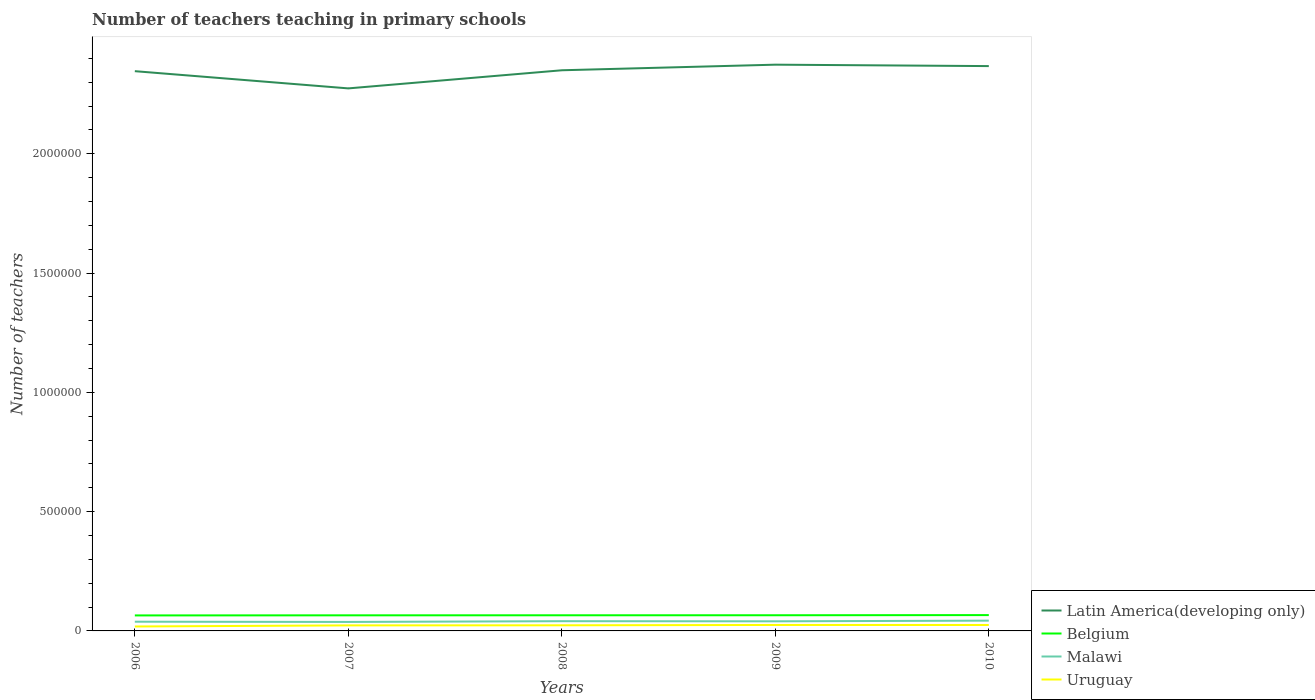Across all years, what is the maximum number of teachers teaching in primary schools in Latin America(developing only)?
Provide a succinct answer. 2.27e+06. What is the total number of teachers teaching in primary schools in Latin America(developing only) in the graph?
Your response must be concise. -9.34e+04. What is the difference between the highest and the second highest number of teachers teaching in primary schools in Uruguay?
Provide a succinct answer. 6331. What is the difference between the highest and the lowest number of teachers teaching in primary schools in Belgium?
Your answer should be compact. 2. Is the number of teachers teaching in primary schools in Uruguay strictly greater than the number of teachers teaching in primary schools in Belgium over the years?
Provide a succinct answer. Yes. Are the values on the major ticks of Y-axis written in scientific E-notation?
Provide a succinct answer. No. Does the graph contain any zero values?
Provide a succinct answer. No. Does the graph contain grids?
Your answer should be very brief. No. Where does the legend appear in the graph?
Your response must be concise. Bottom right. What is the title of the graph?
Your response must be concise. Number of teachers teaching in primary schools. Does "Central African Republic" appear as one of the legend labels in the graph?
Offer a very short reply. No. What is the label or title of the X-axis?
Offer a terse response. Years. What is the label or title of the Y-axis?
Ensure brevity in your answer.  Number of teachers. What is the Number of teachers of Latin America(developing only) in 2006?
Give a very brief answer. 2.35e+06. What is the Number of teachers in Belgium in 2006?
Make the answer very short. 6.49e+04. What is the Number of teachers in Malawi in 2006?
Provide a succinct answer. 3.86e+04. What is the Number of teachers of Uruguay in 2006?
Provide a short and direct response. 1.86e+04. What is the Number of teachers of Latin America(developing only) in 2007?
Provide a short and direct response. 2.27e+06. What is the Number of teachers in Belgium in 2007?
Give a very brief answer. 6.54e+04. What is the Number of teachers in Malawi in 2007?
Ensure brevity in your answer.  3.77e+04. What is the Number of teachers of Uruguay in 2007?
Provide a short and direct response. 2.32e+04. What is the Number of teachers in Latin America(developing only) in 2008?
Your response must be concise. 2.35e+06. What is the Number of teachers in Belgium in 2008?
Provide a succinct answer. 6.56e+04. What is the Number of teachers in Malawi in 2008?
Your answer should be very brief. 4.08e+04. What is the Number of teachers of Uruguay in 2008?
Your answer should be compact. 2.36e+04. What is the Number of teachers in Latin America(developing only) in 2009?
Provide a short and direct response. 2.37e+06. What is the Number of teachers of Belgium in 2009?
Make the answer very short. 6.57e+04. What is the Number of teachers in Malawi in 2009?
Offer a terse response. 4.03e+04. What is the Number of teachers in Uruguay in 2009?
Ensure brevity in your answer.  2.49e+04. What is the Number of teachers of Latin America(developing only) in 2010?
Provide a short and direct response. 2.37e+06. What is the Number of teachers in Belgium in 2010?
Provide a short and direct response. 6.63e+04. What is the Number of teachers of Malawi in 2010?
Give a very brief answer. 4.31e+04. What is the Number of teachers of Uruguay in 2010?
Provide a short and direct response. 2.48e+04. Across all years, what is the maximum Number of teachers of Latin America(developing only)?
Offer a very short reply. 2.37e+06. Across all years, what is the maximum Number of teachers in Belgium?
Your response must be concise. 6.63e+04. Across all years, what is the maximum Number of teachers of Malawi?
Offer a very short reply. 4.31e+04. Across all years, what is the maximum Number of teachers of Uruguay?
Offer a terse response. 2.49e+04. Across all years, what is the minimum Number of teachers of Latin America(developing only)?
Your response must be concise. 2.27e+06. Across all years, what is the minimum Number of teachers in Belgium?
Offer a very short reply. 6.49e+04. Across all years, what is the minimum Number of teachers in Malawi?
Keep it short and to the point. 3.77e+04. Across all years, what is the minimum Number of teachers in Uruguay?
Offer a terse response. 1.86e+04. What is the total Number of teachers of Latin America(developing only) in the graph?
Your response must be concise. 1.17e+07. What is the total Number of teachers of Belgium in the graph?
Provide a succinct answer. 3.28e+05. What is the total Number of teachers in Malawi in the graph?
Keep it short and to the point. 2.00e+05. What is the total Number of teachers of Uruguay in the graph?
Give a very brief answer. 1.15e+05. What is the difference between the Number of teachers of Latin America(developing only) in 2006 and that in 2007?
Give a very brief answer. 7.22e+04. What is the difference between the Number of teachers of Belgium in 2006 and that in 2007?
Offer a terse response. -431. What is the difference between the Number of teachers in Malawi in 2006 and that in 2007?
Offer a terse response. 951. What is the difference between the Number of teachers in Uruguay in 2006 and that in 2007?
Make the answer very short. -4575. What is the difference between the Number of teachers of Latin America(developing only) in 2006 and that in 2008?
Provide a short and direct response. -3760.25. What is the difference between the Number of teachers of Belgium in 2006 and that in 2008?
Give a very brief answer. -627. What is the difference between the Number of teachers of Malawi in 2006 and that in 2008?
Provide a succinct answer. -2161. What is the difference between the Number of teachers in Uruguay in 2006 and that in 2008?
Provide a short and direct response. -4955. What is the difference between the Number of teachers in Latin America(developing only) in 2006 and that in 2009?
Your answer should be very brief. -2.72e+04. What is the difference between the Number of teachers in Belgium in 2006 and that in 2009?
Offer a very short reply. -721. What is the difference between the Number of teachers of Malawi in 2006 and that in 2009?
Offer a very short reply. -1658. What is the difference between the Number of teachers in Uruguay in 2006 and that in 2009?
Offer a terse response. -6331. What is the difference between the Number of teachers of Latin America(developing only) in 2006 and that in 2010?
Provide a succinct answer. -2.13e+04. What is the difference between the Number of teachers of Belgium in 2006 and that in 2010?
Give a very brief answer. -1370. What is the difference between the Number of teachers of Malawi in 2006 and that in 2010?
Give a very brief answer. -4484. What is the difference between the Number of teachers in Uruguay in 2006 and that in 2010?
Offer a terse response. -6185. What is the difference between the Number of teachers in Latin America(developing only) in 2007 and that in 2008?
Offer a terse response. -7.59e+04. What is the difference between the Number of teachers of Belgium in 2007 and that in 2008?
Your answer should be compact. -196. What is the difference between the Number of teachers of Malawi in 2007 and that in 2008?
Offer a very short reply. -3112. What is the difference between the Number of teachers in Uruguay in 2007 and that in 2008?
Your answer should be compact. -380. What is the difference between the Number of teachers of Latin America(developing only) in 2007 and that in 2009?
Your response must be concise. -9.94e+04. What is the difference between the Number of teachers of Belgium in 2007 and that in 2009?
Your response must be concise. -290. What is the difference between the Number of teachers in Malawi in 2007 and that in 2009?
Make the answer very short. -2609. What is the difference between the Number of teachers of Uruguay in 2007 and that in 2009?
Provide a short and direct response. -1756. What is the difference between the Number of teachers of Latin America(developing only) in 2007 and that in 2010?
Your answer should be compact. -9.34e+04. What is the difference between the Number of teachers of Belgium in 2007 and that in 2010?
Provide a succinct answer. -939. What is the difference between the Number of teachers of Malawi in 2007 and that in 2010?
Ensure brevity in your answer.  -5435. What is the difference between the Number of teachers in Uruguay in 2007 and that in 2010?
Your answer should be compact. -1610. What is the difference between the Number of teachers in Latin America(developing only) in 2008 and that in 2009?
Offer a very short reply. -2.35e+04. What is the difference between the Number of teachers in Belgium in 2008 and that in 2009?
Your answer should be compact. -94. What is the difference between the Number of teachers in Malawi in 2008 and that in 2009?
Your answer should be compact. 503. What is the difference between the Number of teachers in Uruguay in 2008 and that in 2009?
Make the answer very short. -1376. What is the difference between the Number of teachers of Latin America(developing only) in 2008 and that in 2010?
Make the answer very short. -1.75e+04. What is the difference between the Number of teachers of Belgium in 2008 and that in 2010?
Offer a very short reply. -743. What is the difference between the Number of teachers in Malawi in 2008 and that in 2010?
Provide a short and direct response. -2323. What is the difference between the Number of teachers in Uruguay in 2008 and that in 2010?
Your response must be concise. -1230. What is the difference between the Number of teachers in Latin America(developing only) in 2009 and that in 2010?
Your response must be concise. 5993.25. What is the difference between the Number of teachers of Belgium in 2009 and that in 2010?
Ensure brevity in your answer.  -649. What is the difference between the Number of teachers in Malawi in 2009 and that in 2010?
Keep it short and to the point. -2826. What is the difference between the Number of teachers of Uruguay in 2009 and that in 2010?
Your response must be concise. 146. What is the difference between the Number of teachers of Latin America(developing only) in 2006 and the Number of teachers of Belgium in 2007?
Provide a succinct answer. 2.28e+06. What is the difference between the Number of teachers of Latin America(developing only) in 2006 and the Number of teachers of Malawi in 2007?
Provide a succinct answer. 2.31e+06. What is the difference between the Number of teachers in Latin America(developing only) in 2006 and the Number of teachers in Uruguay in 2007?
Make the answer very short. 2.32e+06. What is the difference between the Number of teachers of Belgium in 2006 and the Number of teachers of Malawi in 2007?
Your answer should be compact. 2.73e+04. What is the difference between the Number of teachers of Belgium in 2006 and the Number of teachers of Uruguay in 2007?
Give a very brief answer. 4.18e+04. What is the difference between the Number of teachers in Malawi in 2006 and the Number of teachers in Uruguay in 2007?
Your answer should be compact. 1.55e+04. What is the difference between the Number of teachers of Latin America(developing only) in 2006 and the Number of teachers of Belgium in 2008?
Provide a succinct answer. 2.28e+06. What is the difference between the Number of teachers of Latin America(developing only) in 2006 and the Number of teachers of Malawi in 2008?
Keep it short and to the point. 2.31e+06. What is the difference between the Number of teachers of Latin America(developing only) in 2006 and the Number of teachers of Uruguay in 2008?
Keep it short and to the point. 2.32e+06. What is the difference between the Number of teachers of Belgium in 2006 and the Number of teachers of Malawi in 2008?
Offer a terse response. 2.42e+04. What is the difference between the Number of teachers in Belgium in 2006 and the Number of teachers in Uruguay in 2008?
Ensure brevity in your answer.  4.14e+04. What is the difference between the Number of teachers of Malawi in 2006 and the Number of teachers of Uruguay in 2008?
Ensure brevity in your answer.  1.51e+04. What is the difference between the Number of teachers in Latin America(developing only) in 2006 and the Number of teachers in Belgium in 2009?
Ensure brevity in your answer.  2.28e+06. What is the difference between the Number of teachers of Latin America(developing only) in 2006 and the Number of teachers of Malawi in 2009?
Give a very brief answer. 2.31e+06. What is the difference between the Number of teachers of Latin America(developing only) in 2006 and the Number of teachers of Uruguay in 2009?
Make the answer very short. 2.32e+06. What is the difference between the Number of teachers in Belgium in 2006 and the Number of teachers in Malawi in 2009?
Make the answer very short. 2.47e+04. What is the difference between the Number of teachers of Belgium in 2006 and the Number of teachers of Uruguay in 2009?
Offer a very short reply. 4.00e+04. What is the difference between the Number of teachers in Malawi in 2006 and the Number of teachers in Uruguay in 2009?
Provide a short and direct response. 1.37e+04. What is the difference between the Number of teachers in Latin America(developing only) in 2006 and the Number of teachers in Belgium in 2010?
Give a very brief answer. 2.28e+06. What is the difference between the Number of teachers of Latin America(developing only) in 2006 and the Number of teachers of Malawi in 2010?
Your answer should be very brief. 2.30e+06. What is the difference between the Number of teachers of Latin America(developing only) in 2006 and the Number of teachers of Uruguay in 2010?
Offer a very short reply. 2.32e+06. What is the difference between the Number of teachers of Belgium in 2006 and the Number of teachers of Malawi in 2010?
Your answer should be compact. 2.18e+04. What is the difference between the Number of teachers of Belgium in 2006 and the Number of teachers of Uruguay in 2010?
Your answer should be compact. 4.02e+04. What is the difference between the Number of teachers of Malawi in 2006 and the Number of teachers of Uruguay in 2010?
Your answer should be very brief. 1.38e+04. What is the difference between the Number of teachers in Latin America(developing only) in 2007 and the Number of teachers in Belgium in 2008?
Give a very brief answer. 2.21e+06. What is the difference between the Number of teachers in Latin America(developing only) in 2007 and the Number of teachers in Malawi in 2008?
Your answer should be very brief. 2.23e+06. What is the difference between the Number of teachers in Latin America(developing only) in 2007 and the Number of teachers in Uruguay in 2008?
Offer a terse response. 2.25e+06. What is the difference between the Number of teachers of Belgium in 2007 and the Number of teachers of Malawi in 2008?
Provide a succinct answer. 2.46e+04. What is the difference between the Number of teachers of Belgium in 2007 and the Number of teachers of Uruguay in 2008?
Offer a terse response. 4.18e+04. What is the difference between the Number of teachers of Malawi in 2007 and the Number of teachers of Uruguay in 2008?
Your response must be concise. 1.41e+04. What is the difference between the Number of teachers of Latin America(developing only) in 2007 and the Number of teachers of Belgium in 2009?
Ensure brevity in your answer.  2.21e+06. What is the difference between the Number of teachers in Latin America(developing only) in 2007 and the Number of teachers in Malawi in 2009?
Provide a succinct answer. 2.23e+06. What is the difference between the Number of teachers in Latin America(developing only) in 2007 and the Number of teachers in Uruguay in 2009?
Ensure brevity in your answer.  2.25e+06. What is the difference between the Number of teachers of Belgium in 2007 and the Number of teachers of Malawi in 2009?
Provide a short and direct response. 2.51e+04. What is the difference between the Number of teachers in Belgium in 2007 and the Number of teachers in Uruguay in 2009?
Make the answer very short. 4.04e+04. What is the difference between the Number of teachers of Malawi in 2007 and the Number of teachers of Uruguay in 2009?
Your answer should be compact. 1.27e+04. What is the difference between the Number of teachers of Latin America(developing only) in 2007 and the Number of teachers of Belgium in 2010?
Offer a very short reply. 2.21e+06. What is the difference between the Number of teachers in Latin America(developing only) in 2007 and the Number of teachers in Malawi in 2010?
Offer a very short reply. 2.23e+06. What is the difference between the Number of teachers in Latin America(developing only) in 2007 and the Number of teachers in Uruguay in 2010?
Your answer should be very brief. 2.25e+06. What is the difference between the Number of teachers of Belgium in 2007 and the Number of teachers of Malawi in 2010?
Give a very brief answer. 2.23e+04. What is the difference between the Number of teachers of Belgium in 2007 and the Number of teachers of Uruguay in 2010?
Provide a short and direct response. 4.06e+04. What is the difference between the Number of teachers of Malawi in 2007 and the Number of teachers of Uruguay in 2010?
Provide a succinct answer. 1.29e+04. What is the difference between the Number of teachers in Latin America(developing only) in 2008 and the Number of teachers in Belgium in 2009?
Make the answer very short. 2.28e+06. What is the difference between the Number of teachers in Latin America(developing only) in 2008 and the Number of teachers in Malawi in 2009?
Offer a terse response. 2.31e+06. What is the difference between the Number of teachers in Latin America(developing only) in 2008 and the Number of teachers in Uruguay in 2009?
Make the answer very short. 2.32e+06. What is the difference between the Number of teachers of Belgium in 2008 and the Number of teachers of Malawi in 2009?
Ensure brevity in your answer.  2.53e+04. What is the difference between the Number of teachers of Belgium in 2008 and the Number of teachers of Uruguay in 2009?
Provide a short and direct response. 4.06e+04. What is the difference between the Number of teachers in Malawi in 2008 and the Number of teachers in Uruguay in 2009?
Offer a very short reply. 1.59e+04. What is the difference between the Number of teachers of Latin America(developing only) in 2008 and the Number of teachers of Belgium in 2010?
Ensure brevity in your answer.  2.28e+06. What is the difference between the Number of teachers of Latin America(developing only) in 2008 and the Number of teachers of Malawi in 2010?
Provide a short and direct response. 2.31e+06. What is the difference between the Number of teachers of Latin America(developing only) in 2008 and the Number of teachers of Uruguay in 2010?
Ensure brevity in your answer.  2.32e+06. What is the difference between the Number of teachers in Belgium in 2008 and the Number of teachers in Malawi in 2010?
Provide a succinct answer. 2.25e+04. What is the difference between the Number of teachers in Belgium in 2008 and the Number of teachers in Uruguay in 2010?
Your answer should be very brief. 4.08e+04. What is the difference between the Number of teachers of Malawi in 2008 and the Number of teachers of Uruguay in 2010?
Make the answer very short. 1.60e+04. What is the difference between the Number of teachers in Latin America(developing only) in 2009 and the Number of teachers in Belgium in 2010?
Offer a terse response. 2.31e+06. What is the difference between the Number of teachers of Latin America(developing only) in 2009 and the Number of teachers of Malawi in 2010?
Give a very brief answer. 2.33e+06. What is the difference between the Number of teachers of Latin America(developing only) in 2009 and the Number of teachers of Uruguay in 2010?
Make the answer very short. 2.35e+06. What is the difference between the Number of teachers in Belgium in 2009 and the Number of teachers in Malawi in 2010?
Ensure brevity in your answer.  2.26e+04. What is the difference between the Number of teachers in Belgium in 2009 and the Number of teachers in Uruguay in 2010?
Your answer should be very brief. 4.09e+04. What is the difference between the Number of teachers in Malawi in 2009 and the Number of teachers in Uruguay in 2010?
Provide a short and direct response. 1.55e+04. What is the average Number of teachers of Latin America(developing only) per year?
Offer a terse response. 2.34e+06. What is the average Number of teachers of Belgium per year?
Make the answer very short. 6.56e+04. What is the average Number of teachers in Malawi per year?
Your answer should be very brief. 4.01e+04. What is the average Number of teachers of Uruguay per year?
Offer a terse response. 2.30e+04. In the year 2006, what is the difference between the Number of teachers of Latin America(developing only) and Number of teachers of Belgium?
Provide a succinct answer. 2.28e+06. In the year 2006, what is the difference between the Number of teachers in Latin America(developing only) and Number of teachers in Malawi?
Provide a short and direct response. 2.31e+06. In the year 2006, what is the difference between the Number of teachers of Latin America(developing only) and Number of teachers of Uruguay?
Keep it short and to the point. 2.33e+06. In the year 2006, what is the difference between the Number of teachers in Belgium and Number of teachers in Malawi?
Offer a very short reply. 2.63e+04. In the year 2006, what is the difference between the Number of teachers in Belgium and Number of teachers in Uruguay?
Keep it short and to the point. 4.63e+04. In the year 2006, what is the difference between the Number of teachers of Malawi and Number of teachers of Uruguay?
Your answer should be very brief. 2.00e+04. In the year 2007, what is the difference between the Number of teachers of Latin America(developing only) and Number of teachers of Belgium?
Your answer should be compact. 2.21e+06. In the year 2007, what is the difference between the Number of teachers in Latin America(developing only) and Number of teachers in Malawi?
Your answer should be compact. 2.24e+06. In the year 2007, what is the difference between the Number of teachers in Latin America(developing only) and Number of teachers in Uruguay?
Offer a terse response. 2.25e+06. In the year 2007, what is the difference between the Number of teachers of Belgium and Number of teachers of Malawi?
Offer a terse response. 2.77e+04. In the year 2007, what is the difference between the Number of teachers in Belgium and Number of teachers in Uruguay?
Offer a very short reply. 4.22e+04. In the year 2007, what is the difference between the Number of teachers of Malawi and Number of teachers of Uruguay?
Keep it short and to the point. 1.45e+04. In the year 2008, what is the difference between the Number of teachers of Latin America(developing only) and Number of teachers of Belgium?
Your response must be concise. 2.28e+06. In the year 2008, what is the difference between the Number of teachers in Latin America(developing only) and Number of teachers in Malawi?
Offer a very short reply. 2.31e+06. In the year 2008, what is the difference between the Number of teachers in Latin America(developing only) and Number of teachers in Uruguay?
Provide a short and direct response. 2.33e+06. In the year 2008, what is the difference between the Number of teachers in Belgium and Number of teachers in Malawi?
Your answer should be very brief. 2.48e+04. In the year 2008, what is the difference between the Number of teachers of Belgium and Number of teachers of Uruguay?
Your response must be concise. 4.20e+04. In the year 2008, what is the difference between the Number of teachers of Malawi and Number of teachers of Uruguay?
Make the answer very short. 1.72e+04. In the year 2009, what is the difference between the Number of teachers in Latin America(developing only) and Number of teachers in Belgium?
Provide a short and direct response. 2.31e+06. In the year 2009, what is the difference between the Number of teachers of Latin America(developing only) and Number of teachers of Malawi?
Provide a short and direct response. 2.33e+06. In the year 2009, what is the difference between the Number of teachers in Latin America(developing only) and Number of teachers in Uruguay?
Offer a terse response. 2.35e+06. In the year 2009, what is the difference between the Number of teachers of Belgium and Number of teachers of Malawi?
Provide a short and direct response. 2.54e+04. In the year 2009, what is the difference between the Number of teachers in Belgium and Number of teachers in Uruguay?
Offer a very short reply. 4.07e+04. In the year 2009, what is the difference between the Number of teachers of Malawi and Number of teachers of Uruguay?
Give a very brief answer. 1.54e+04. In the year 2010, what is the difference between the Number of teachers of Latin America(developing only) and Number of teachers of Belgium?
Your response must be concise. 2.30e+06. In the year 2010, what is the difference between the Number of teachers in Latin America(developing only) and Number of teachers in Malawi?
Provide a short and direct response. 2.32e+06. In the year 2010, what is the difference between the Number of teachers in Latin America(developing only) and Number of teachers in Uruguay?
Keep it short and to the point. 2.34e+06. In the year 2010, what is the difference between the Number of teachers of Belgium and Number of teachers of Malawi?
Your answer should be very brief. 2.32e+04. In the year 2010, what is the difference between the Number of teachers of Belgium and Number of teachers of Uruguay?
Ensure brevity in your answer.  4.15e+04. In the year 2010, what is the difference between the Number of teachers in Malawi and Number of teachers in Uruguay?
Give a very brief answer. 1.83e+04. What is the ratio of the Number of teachers in Latin America(developing only) in 2006 to that in 2007?
Your answer should be very brief. 1.03. What is the ratio of the Number of teachers in Belgium in 2006 to that in 2007?
Keep it short and to the point. 0.99. What is the ratio of the Number of teachers in Malawi in 2006 to that in 2007?
Your answer should be compact. 1.03. What is the ratio of the Number of teachers of Uruguay in 2006 to that in 2007?
Your answer should be very brief. 0.8. What is the ratio of the Number of teachers of Latin America(developing only) in 2006 to that in 2008?
Your response must be concise. 1. What is the ratio of the Number of teachers of Malawi in 2006 to that in 2008?
Keep it short and to the point. 0.95. What is the ratio of the Number of teachers in Uruguay in 2006 to that in 2008?
Your response must be concise. 0.79. What is the ratio of the Number of teachers of Latin America(developing only) in 2006 to that in 2009?
Offer a terse response. 0.99. What is the ratio of the Number of teachers of Malawi in 2006 to that in 2009?
Provide a short and direct response. 0.96. What is the ratio of the Number of teachers in Uruguay in 2006 to that in 2009?
Offer a very short reply. 0.75. What is the ratio of the Number of teachers in Belgium in 2006 to that in 2010?
Offer a terse response. 0.98. What is the ratio of the Number of teachers of Malawi in 2006 to that in 2010?
Offer a terse response. 0.9. What is the ratio of the Number of teachers in Uruguay in 2006 to that in 2010?
Make the answer very short. 0.75. What is the ratio of the Number of teachers of Latin America(developing only) in 2007 to that in 2008?
Give a very brief answer. 0.97. What is the ratio of the Number of teachers in Malawi in 2007 to that in 2008?
Keep it short and to the point. 0.92. What is the ratio of the Number of teachers of Uruguay in 2007 to that in 2008?
Offer a very short reply. 0.98. What is the ratio of the Number of teachers in Latin America(developing only) in 2007 to that in 2009?
Offer a very short reply. 0.96. What is the ratio of the Number of teachers of Malawi in 2007 to that in 2009?
Give a very brief answer. 0.94. What is the ratio of the Number of teachers in Uruguay in 2007 to that in 2009?
Your answer should be very brief. 0.93. What is the ratio of the Number of teachers of Latin America(developing only) in 2007 to that in 2010?
Provide a succinct answer. 0.96. What is the ratio of the Number of teachers of Belgium in 2007 to that in 2010?
Your response must be concise. 0.99. What is the ratio of the Number of teachers in Malawi in 2007 to that in 2010?
Keep it short and to the point. 0.87. What is the ratio of the Number of teachers in Uruguay in 2007 to that in 2010?
Offer a very short reply. 0.94. What is the ratio of the Number of teachers in Malawi in 2008 to that in 2009?
Make the answer very short. 1.01. What is the ratio of the Number of teachers in Uruguay in 2008 to that in 2009?
Offer a terse response. 0.94. What is the ratio of the Number of teachers in Malawi in 2008 to that in 2010?
Your response must be concise. 0.95. What is the ratio of the Number of teachers of Uruguay in 2008 to that in 2010?
Provide a short and direct response. 0.95. What is the ratio of the Number of teachers in Latin America(developing only) in 2009 to that in 2010?
Make the answer very short. 1. What is the ratio of the Number of teachers in Belgium in 2009 to that in 2010?
Your answer should be compact. 0.99. What is the ratio of the Number of teachers of Malawi in 2009 to that in 2010?
Provide a short and direct response. 0.93. What is the ratio of the Number of teachers of Uruguay in 2009 to that in 2010?
Provide a short and direct response. 1.01. What is the difference between the highest and the second highest Number of teachers in Latin America(developing only)?
Keep it short and to the point. 5993.25. What is the difference between the highest and the second highest Number of teachers in Belgium?
Keep it short and to the point. 649. What is the difference between the highest and the second highest Number of teachers in Malawi?
Provide a short and direct response. 2323. What is the difference between the highest and the second highest Number of teachers in Uruguay?
Provide a short and direct response. 146. What is the difference between the highest and the lowest Number of teachers in Latin America(developing only)?
Your response must be concise. 9.94e+04. What is the difference between the highest and the lowest Number of teachers in Belgium?
Your answer should be compact. 1370. What is the difference between the highest and the lowest Number of teachers in Malawi?
Your answer should be very brief. 5435. What is the difference between the highest and the lowest Number of teachers of Uruguay?
Provide a short and direct response. 6331. 